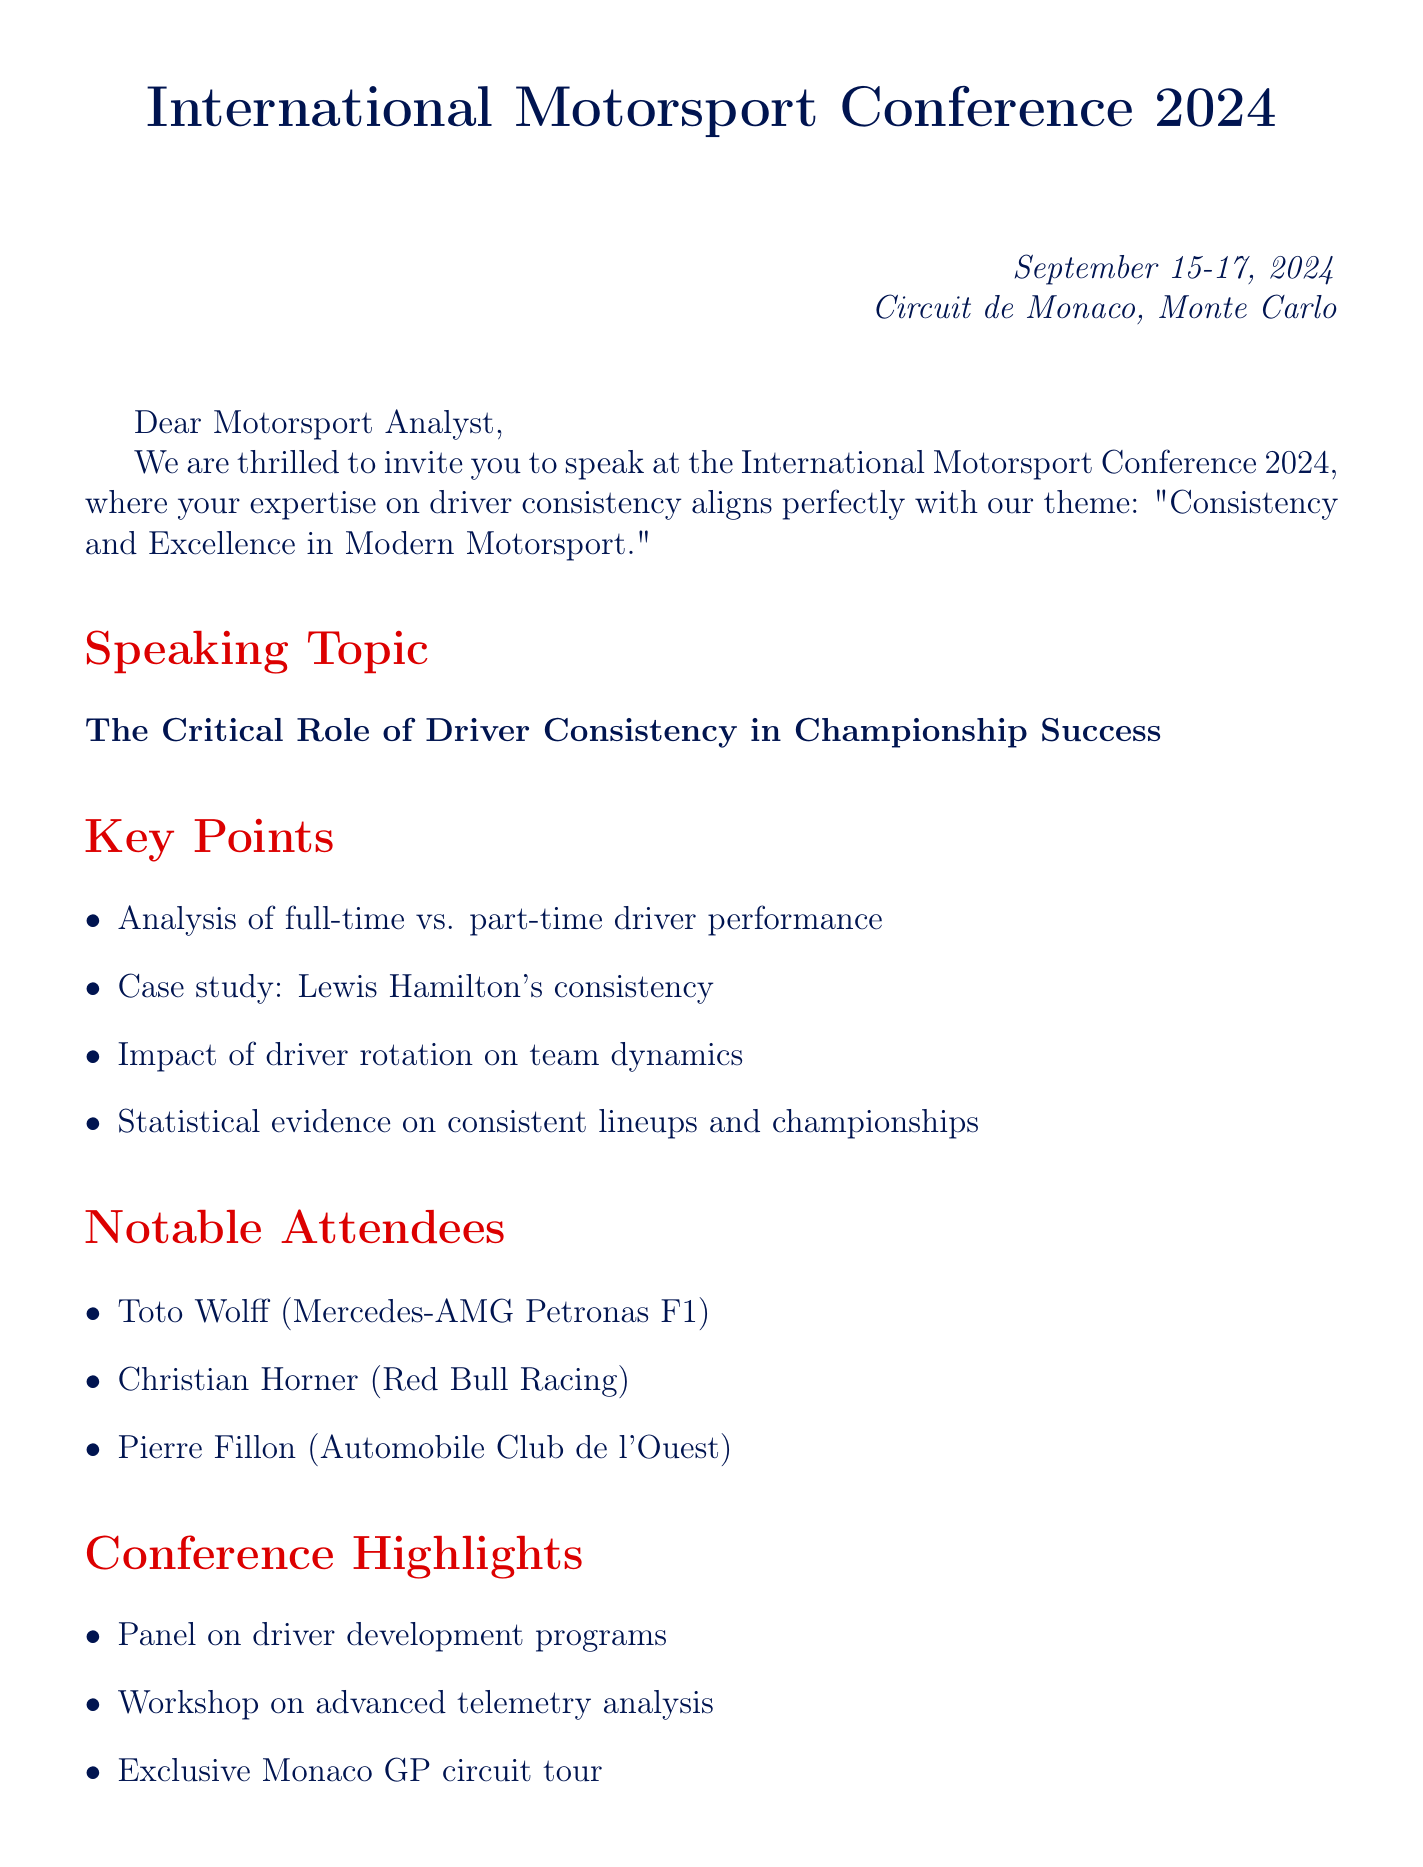What is the date of the conference? The date of the conference is specified in the document.
Answer: September 15-17, 2024 Where is the conference held? The location of the conference is mentioned in the event details.
Answer: Circuit de Monaco, Monte Carlo What is the theme of the conference? The theme reflects the overall focus of the event as stated in the document.
Answer: Consistency and Excellence in Modern Motorsport Who is a notable attendee from Mercedes-AMG? This question asks for a specific name listed among notable attendees.
Answer: Toto Wolff What case study is mentioned in the key points? This requires identifying the specific example used to support the main topic.
Answer: Lewis Hamilton's consistency What is one benefit for speakers? The document provides details regarding the advantages granted to speakers.
Answer: Complimentary conference pass How many key points are listed in the document? This counts the items presented under the key points section.
Answer: Four Which topic does the panel discussion cover? This question looks for the subject of one of the conference highlights.
Answer: Driver development programs How does the invitation regard the recipient's skepticism? This looks for how the invitation perceives the recipient's viewpoint.
Answer: Valuable insights 